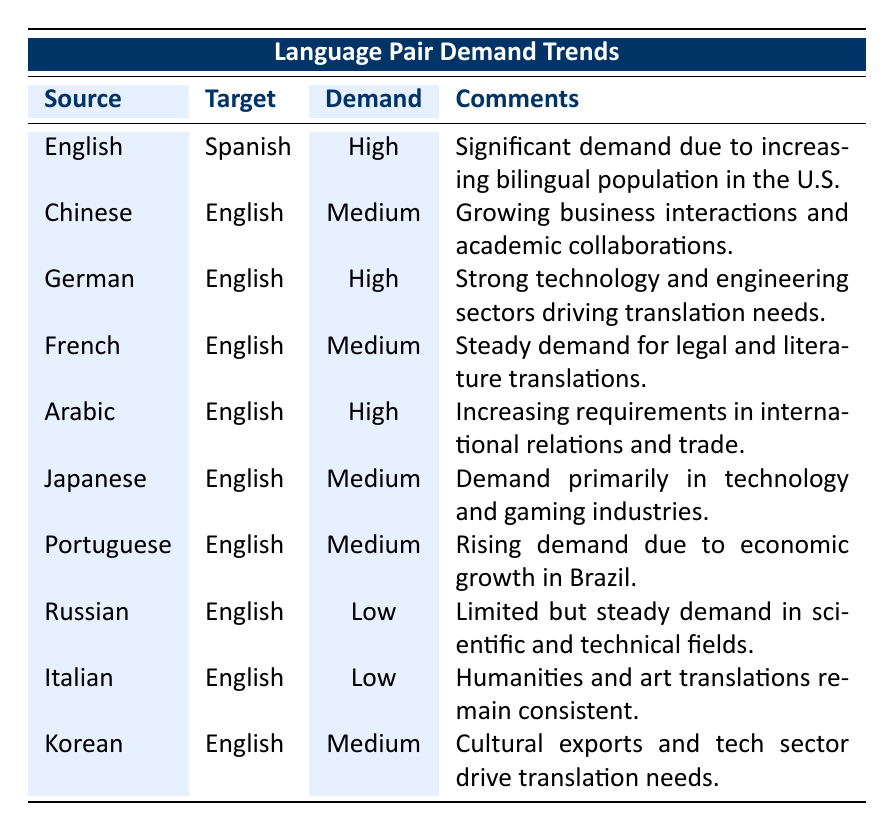What is the demand trend for the English to Spanish language pair? The table shows that the demand trend for the English to Spanish language pair is categorized as "High".
Answer: High Which language pair has a low demand trend? The table lists two language pairs with a low demand trend: Russian to English and Italian to English.
Answer: Russian to English, Italian to English What is the demand trend for Arabic to English compared to French to English? The demand trend for Arabic to English is "High", while for French to English, it is "Medium". This indicates that the demand for Arabic to English translations is stronger than for French to English.
Answer: Arabic to English has high demand, French to English has medium demand How many language pairs have a medium demand trend? There are four language pairs with a medium demand trend: Chinese to English, French to English, Japanese to English, and Korean to English. Therefore, the total count is four.
Answer: 4 Is there a demand trend for Japanese to English? Yes, the demand trend for Japanese to English is categorized as "Medium".
Answer: Yes What is the combined demand trend for the English to Korean and English to Portuguese language pairs? The demand trend for English to Korean is "Medium" and for English to Portuguese is also "Medium". Therefore, the combined trend is medium since both are at the same level.
Answer: Medium Which source language has the highest demand trend for English translations? The source languages with the highest demand trend for English translations are Arabic and German, both categorized as "High".
Answer: Arabic and German Calculate the number of pairs with "High" demand. There are three language pairs listed with "High" demand: English to Spanish, German to English, and Arabic to English. Thus, the total count is three.
Answer: 3 What factor drives the demand for Chinese to English translations? The table indicates that the demand for Chinese to English translations is driven by growing business interactions and academic collaborations.
Answer: Growing business interactions and academic collaborations 